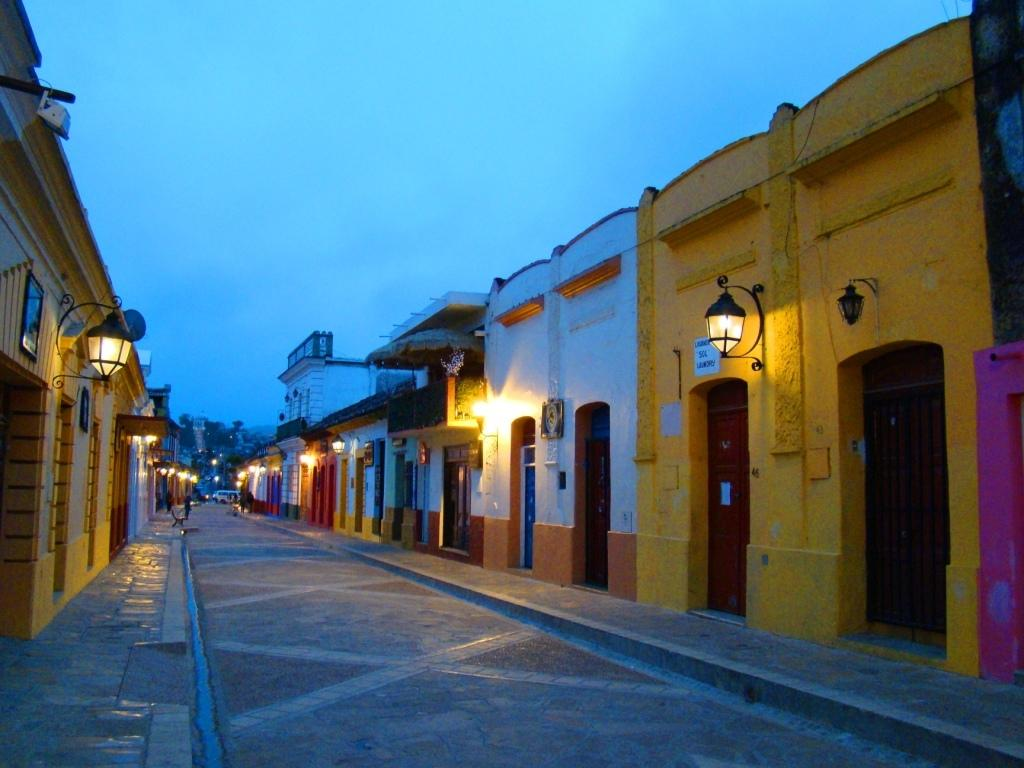What type of structures are located in the middle of the image? There are houses in the middle of the image. What can be seen on either side of the image? There are lights on either side of the image. What is visible at the top of the image? The sky is visible at the top of the image. How many kittens are playing with rabbits in the image? There are no kittens or rabbits present in the image. What type of pollution can be seen in the image? There is no pollution visible in the image. 